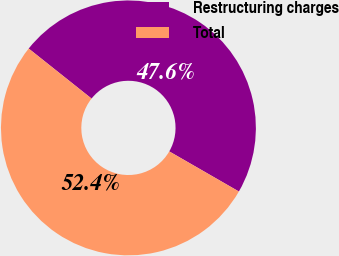Convert chart. <chart><loc_0><loc_0><loc_500><loc_500><pie_chart><fcel>Restructuring charges<fcel>Total<nl><fcel>47.62%<fcel>52.38%<nl></chart> 